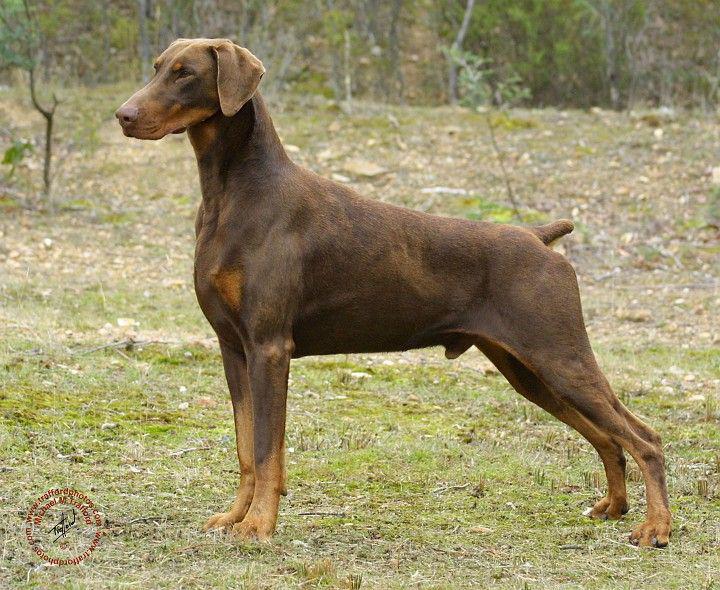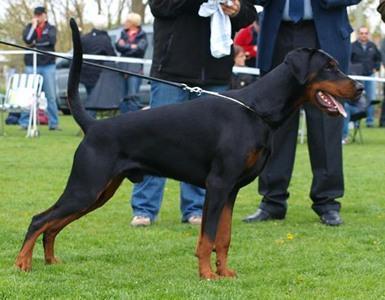The first image is the image on the left, the second image is the image on the right. Assess this claim about the two images: "There are at least three dogs in total.". Correct or not? Answer yes or no. No. The first image is the image on the left, the second image is the image on the right. Considering the images on both sides, is "The right image features two side-by-side forward-facing floppy-eared doberman with collar-like things around their shoulders." valid? Answer yes or no. No. 